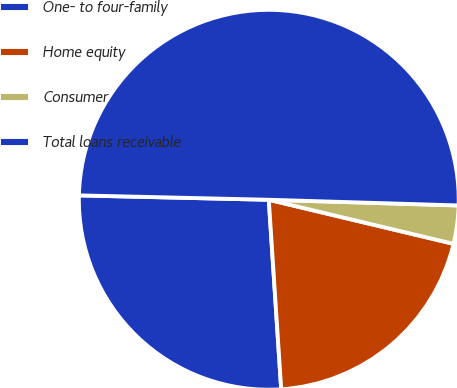Convert chart. <chart><loc_0><loc_0><loc_500><loc_500><pie_chart><fcel>One- to four-family<fcel>Home equity<fcel>Consumer<fcel>Total loans receivable<nl><fcel>26.41%<fcel>20.23%<fcel>3.25%<fcel>50.11%<nl></chart> 